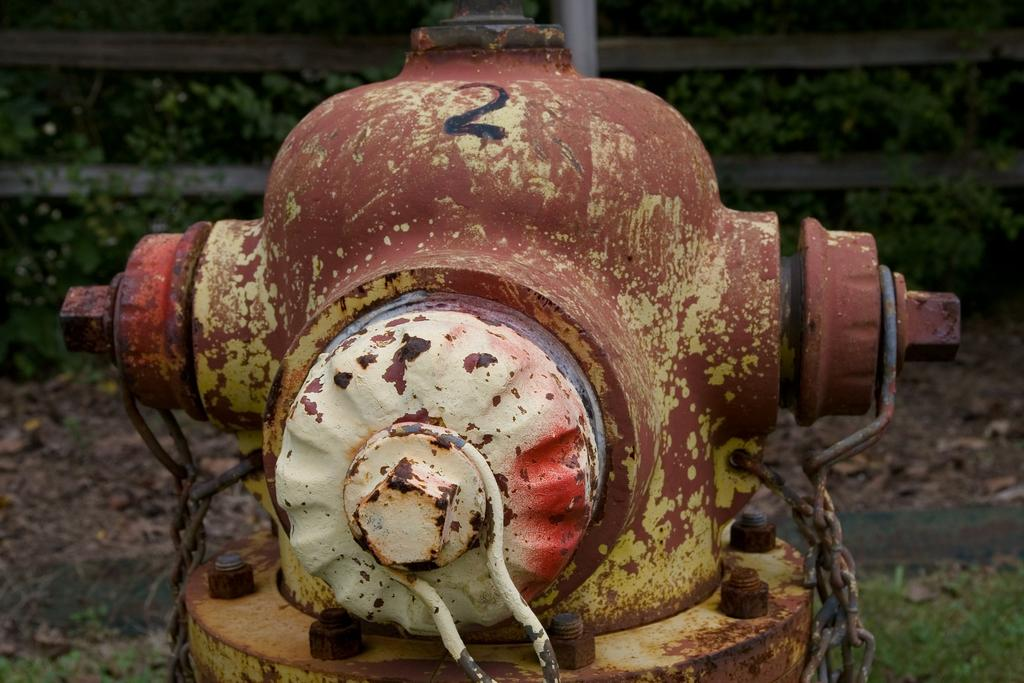What object is located in the foreground of the image? There is a fire extinguisher in the foreground of the image. What other object is present in the foreground of the image? There are chains in the foreground of the image. What can be seen in the background of the image? There is a fence, grass, and a pole in the background of the image. What type of vegetation is present at the bottom of the image? There is grass and plants at the bottom of the image. Can you tell me how many berries are on the fire extinguisher in the image? There are no berries present on the fire extinguisher in the image. What type of thing is used to join the chains together in the image? There is no indication in the image that the chains are joined together, and therefore no such object can be observed. 